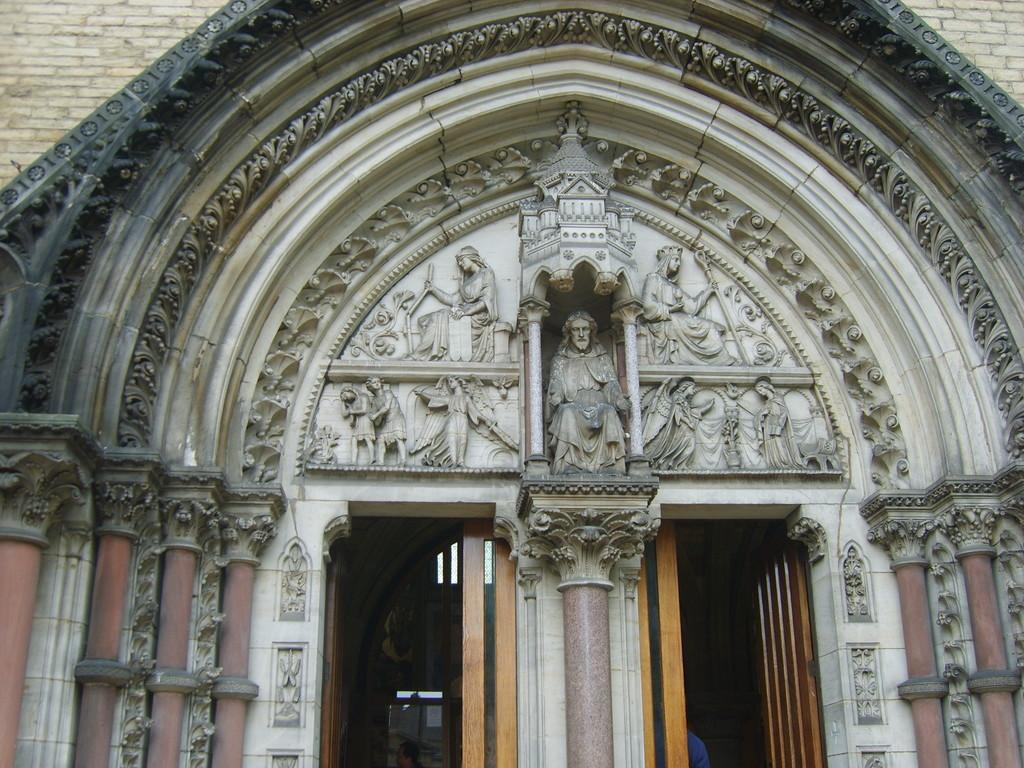What type of structure is present in the image? There is a building in the image. What are the main features of the building? The building has doors and pillars. Are there any decorative elements on the building? Yes, there are sculptures on the building. What type of pie is being served in the building in the image? There is no pie present in the image; it features a building with doors, pillars, and sculptures. Can you tell me how many trains are parked near the building in the image? There are no trains present in the image; it only features a building with doors, pillars, and sculptures. 